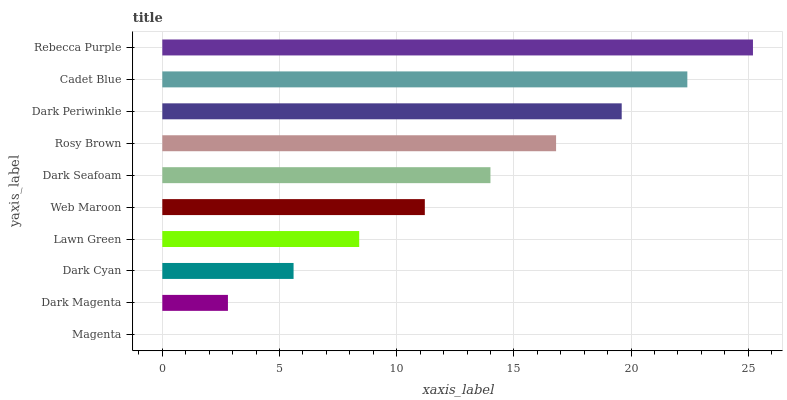Is Magenta the minimum?
Answer yes or no. Yes. Is Rebecca Purple the maximum?
Answer yes or no. Yes. Is Dark Magenta the minimum?
Answer yes or no. No. Is Dark Magenta the maximum?
Answer yes or no. No. Is Dark Magenta greater than Magenta?
Answer yes or no. Yes. Is Magenta less than Dark Magenta?
Answer yes or no. Yes. Is Magenta greater than Dark Magenta?
Answer yes or no. No. Is Dark Magenta less than Magenta?
Answer yes or no. No. Is Dark Seafoam the high median?
Answer yes or no. Yes. Is Web Maroon the low median?
Answer yes or no. Yes. Is Web Maroon the high median?
Answer yes or no. No. Is Dark Seafoam the low median?
Answer yes or no. No. 